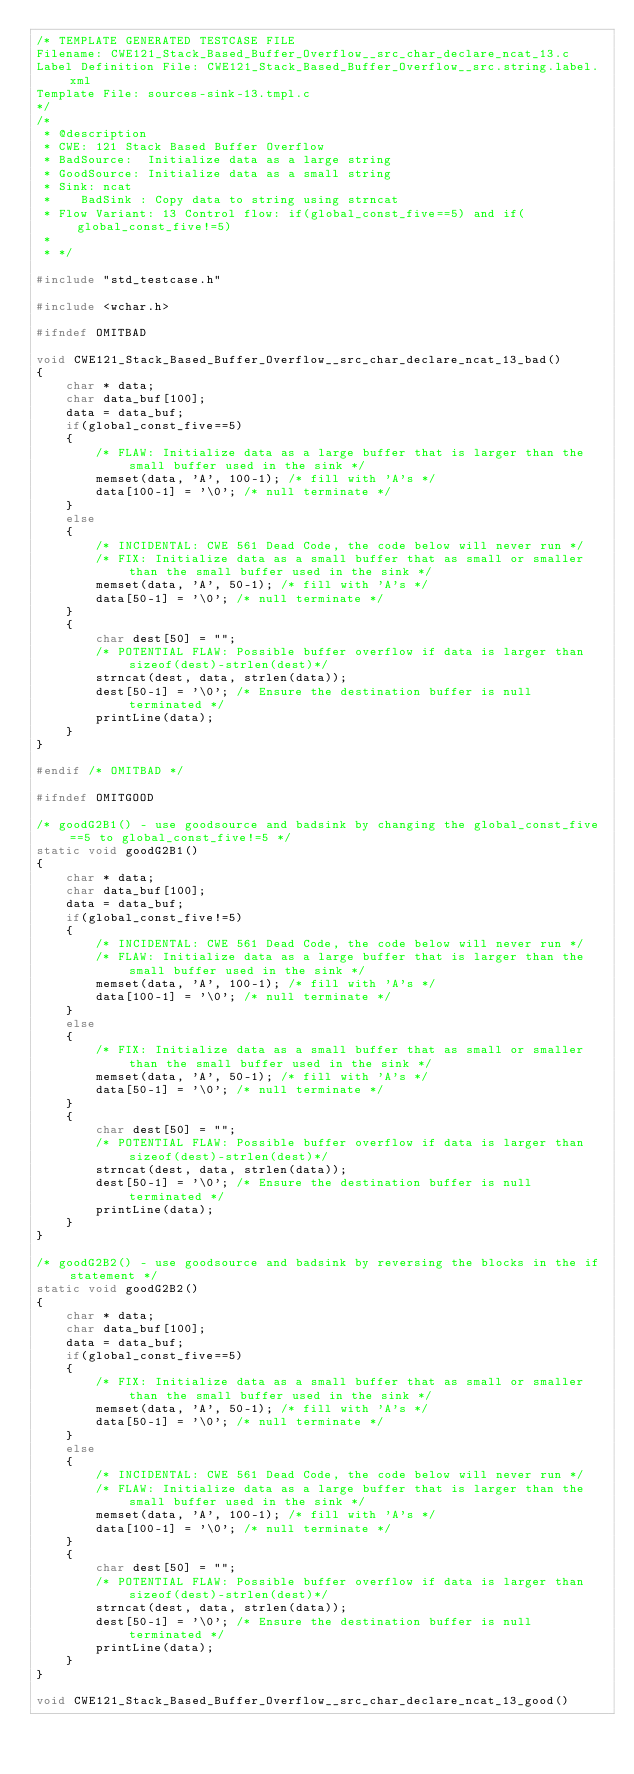Convert code to text. <code><loc_0><loc_0><loc_500><loc_500><_C_>/* TEMPLATE GENERATED TESTCASE FILE
Filename: CWE121_Stack_Based_Buffer_Overflow__src_char_declare_ncat_13.c
Label Definition File: CWE121_Stack_Based_Buffer_Overflow__src.string.label.xml
Template File: sources-sink-13.tmpl.c
*/
/*
 * @description
 * CWE: 121 Stack Based Buffer Overflow
 * BadSource:  Initialize data as a large string
 * GoodSource: Initialize data as a small string
 * Sink: ncat
 *    BadSink : Copy data to string using strncat
 * Flow Variant: 13 Control flow: if(global_const_five==5) and if(global_const_five!=5)
 *
 * */

#include "std_testcase.h"

#include <wchar.h>

#ifndef OMITBAD

void CWE121_Stack_Based_Buffer_Overflow__src_char_declare_ncat_13_bad()
{
    char * data;
    char data_buf[100];
    data = data_buf;
    if(global_const_five==5)
    {
        /* FLAW: Initialize data as a large buffer that is larger than the small buffer used in the sink */
        memset(data, 'A', 100-1); /* fill with 'A's */
        data[100-1] = '\0'; /* null terminate */
    }
    else
    {
        /* INCIDENTAL: CWE 561 Dead Code, the code below will never run */
        /* FIX: Initialize data as a small buffer that as small or smaller than the small buffer used in the sink */
        memset(data, 'A', 50-1); /* fill with 'A's */
        data[50-1] = '\0'; /* null terminate */
    }
    {
        char dest[50] = "";
        /* POTENTIAL FLAW: Possible buffer overflow if data is larger than sizeof(dest)-strlen(dest)*/
        strncat(dest, data, strlen(data));
        dest[50-1] = '\0'; /* Ensure the destination buffer is null terminated */
        printLine(data);
    }
}

#endif /* OMITBAD */

#ifndef OMITGOOD

/* goodG2B1() - use goodsource and badsink by changing the global_const_five==5 to global_const_five!=5 */
static void goodG2B1()
{
    char * data;
    char data_buf[100];
    data = data_buf;
    if(global_const_five!=5)
    {
        /* INCIDENTAL: CWE 561 Dead Code, the code below will never run */
        /* FLAW: Initialize data as a large buffer that is larger than the small buffer used in the sink */
        memset(data, 'A', 100-1); /* fill with 'A's */
        data[100-1] = '\0'; /* null terminate */
    }
    else
    {
        /* FIX: Initialize data as a small buffer that as small or smaller than the small buffer used in the sink */
        memset(data, 'A', 50-1); /* fill with 'A's */
        data[50-1] = '\0'; /* null terminate */
    }
    {
        char dest[50] = "";
        /* POTENTIAL FLAW: Possible buffer overflow if data is larger than sizeof(dest)-strlen(dest)*/
        strncat(dest, data, strlen(data));
        dest[50-1] = '\0'; /* Ensure the destination buffer is null terminated */
        printLine(data);
    }
}

/* goodG2B2() - use goodsource and badsink by reversing the blocks in the if statement */
static void goodG2B2()
{
    char * data;
    char data_buf[100];
    data = data_buf;
    if(global_const_five==5)
    {
        /* FIX: Initialize data as a small buffer that as small or smaller than the small buffer used in the sink */
        memset(data, 'A', 50-1); /* fill with 'A's */
        data[50-1] = '\0'; /* null terminate */
    }
    else
    {
        /* INCIDENTAL: CWE 561 Dead Code, the code below will never run */
        /* FLAW: Initialize data as a large buffer that is larger than the small buffer used in the sink */
        memset(data, 'A', 100-1); /* fill with 'A's */
        data[100-1] = '\0'; /* null terminate */
    }
    {
        char dest[50] = "";
        /* POTENTIAL FLAW: Possible buffer overflow if data is larger than sizeof(dest)-strlen(dest)*/
        strncat(dest, data, strlen(data));
        dest[50-1] = '\0'; /* Ensure the destination buffer is null terminated */
        printLine(data);
    }
}

void CWE121_Stack_Based_Buffer_Overflow__src_char_declare_ncat_13_good()</code> 